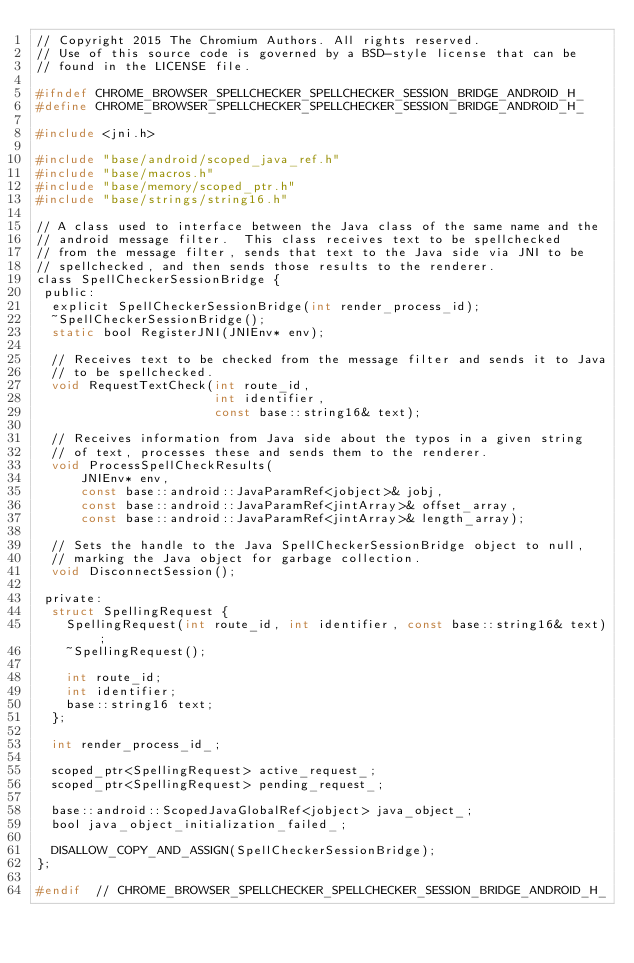<code> <loc_0><loc_0><loc_500><loc_500><_C_>// Copyright 2015 The Chromium Authors. All rights reserved.
// Use of this source code is governed by a BSD-style license that can be
// found in the LICENSE file.

#ifndef CHROME_BROWSER_SPELLCHECKER_SPELLCHECKER_SESSION_BRIDGE_ANDROID_H_
#define CHROME_BROWSER_SPELLCHECKER_SPELLCHECKER_SESSION_BRIDGE_ANDROID_H_

#include <jni.h>

#include "base/android/scoped_java_ref.h"
#include "base/macros.h"
#include "base/memory/scoped_ptr.h"
#include "base/strings/string16.h"

// A class used to interface between the Java class of the same name and the
// android message filter.  This class receives text to be spellchecked
// from the message filter, sends that text to the Java side via JNI to be
// spellchecked, and then sends those results to the renderer.
class SpellCheckerSessionBridge {
 public:
  explicit SpellCheckerSessionBridge(int render_process_id);
  ~SpellCheckerSessionBridge();
  static bool RegisterJNI(JNIEnv* env);

  // Receives text to be checked from the message filter and sends it to Java
  // to be spellchecked.
  void RequestTextCheck(int route_id,
                        int identifier,
                        const base::string16& text);

  // Receives information from Java side about the typos in a given string
  // of text, processes these and sends them to the renderer.
  void ProcessSpellCheckResults(
      JNIEnv* env,
      const base::android::JavaParamRef<jobject>& jobj,
      const base::android::JavaParamRef<jintArray>& offset_array,
      const base::android::JavaParamRef<jintArray>& length_array);

  // Sets the handle to the Java SpellCheckerSessionBridge object to null,
  // marking the Java object for garbage collection.
  void DisconnectSession();

 private:
  struct SpellingRequest {
    SpellingRequest(int route_id, int identifier, const base::string16& text);
    ~SpellingRequest();

    int route_id;
    int identifier;
    base::string16 text;
  };

  int render_process_id_;

  scoped_ptr<SpellingRequest> active_request_;
  scoped_ptr<SpellingRequest> pending_request_;

  base::android::ScopedJavaGlobalRef<jobject> java_object_;
  bool java_object_initialization_failed_;

  DISALLOW_COPY_AND_ASSIGN(SpellCheckerSessionBridge);
};

#endif  // CHROME_BROWSER_SPELLCHECKER_SPELLCHECKER_SESSION_BRIDGE_ANDROID_H_
</code> 